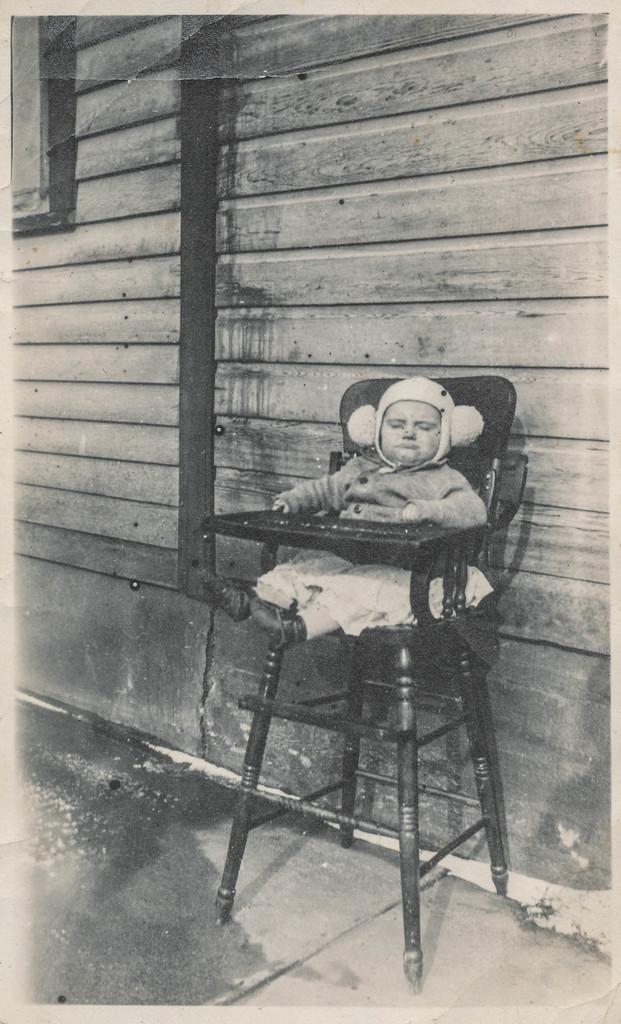In one or two sentences, can you explain what this image depicts? In this image we can see a kid sitting on the chair. In the background there is a wall. 